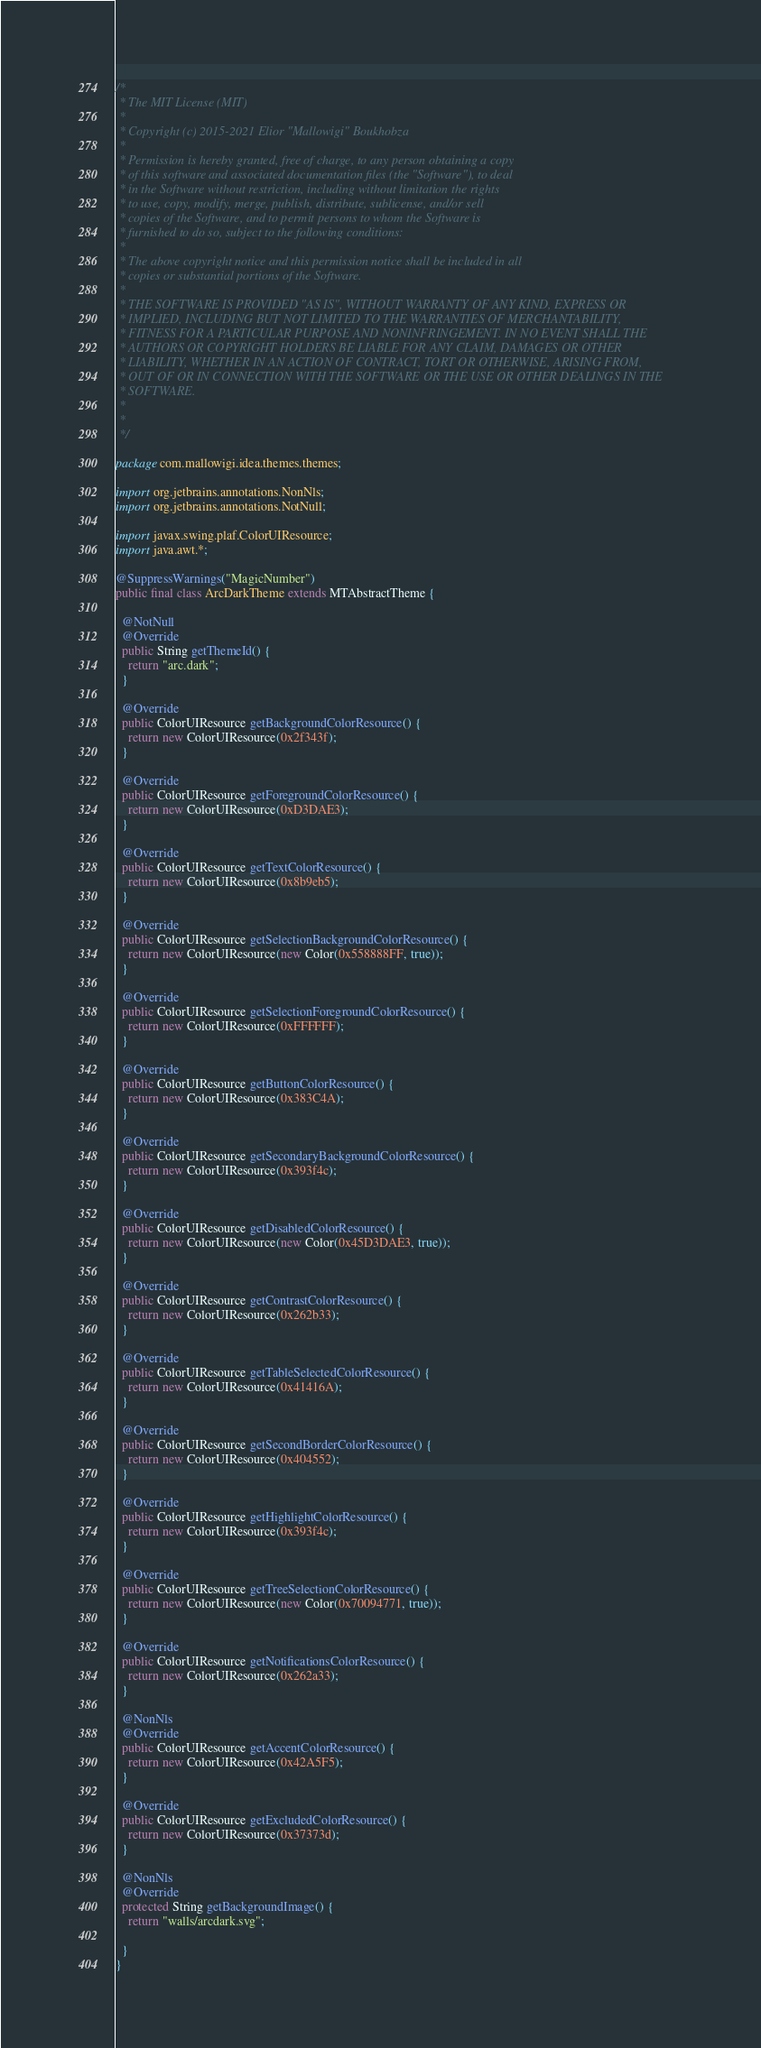Convert code to text. <code><loc_0><loc_0><loc_500><loc_500><_Java_>/*
 * The MIT License (MIT)
 *
 * Copyright (c) 2015-2021 Elior "Mallowigi" Boukhobza
 *
 * Permission is hereby granted, free of charge, to any person obtaining a copy
 * of this software and associated documentation files (the "Software"), to deal
 * in the Software without restriction, including without limitation the rights
 * to use, copy, modify, merge, publish, distribute, sublicense, and/or sell
 * copies of the Software, and to permit persons to whom the Software is
 * furnished to do so, subject to the following conditions:
 *
 * The above copyright notice and this permission notice shall be included in all
 * copies or substantial portions of the Software.
 *
 * THE SOFTWARE IS PROVIDED "AS IS", WITHOUT WARRANTY OF ANY KIND, EXPRESS OR
 * IMPLIED, INCLUDING BUT NOT LIMITED TO THE WARRANTIES OF MERCHANTABILITY,
 * FITNESS FOR A PARTICULAR PURPOSE AND NONINFRINGEMENT. IN NO EVENT SHALL THE
 * AUTHORS OR COPYRIGHT HOLDERS BE LIABLE FOR ANY CLAIM, DAMAGES OR OTHER
 * LIABILITY, WHETHER IN AN ACTION OF CONTRACT, TORT OR OTHERWISE, ARISING FROM,
 * OUT OF OR IN CONNECTION WITH THE SOFTWARE OR THE USE OR OTHER DEALINGS IN THE
 * SOFTWARE.
 *
 *
 */

package com.mallowigi.idea.themes.themes;

import org.jetbrains.annotations.NonNls;
import org.jetbrains.annotations.NotNull;

import javax.swing.plaf.ColorUIResource;
import java.awt.*;

@SuppressWarnings("MagicNumber")
public final class ArcDarkTheme extends MTAbstractTheme {

  @NotNull
  @Override
  public String getThemeId() {
    return "arc.dark";
  }

  @Override
  public ColorUIResource getBackgroundColorResource() {
    return new ColorUIResource(0x2f343f);
  }

  @Override
  public ColorUIResource getForegroundColorResource() {
    return new ColorUIResource(0xD3DAE3);
  }

  @Override
  public ColorUIResource getTextColorResource() {
    return new ColorUIResource(0x8b9eb5);
  }

  @Override
  public ColorUIResource getSelectionBackgroundColorResource() {
    return new ColorUIResource(new Color(0x558888FF, true));
  }

  @Override
  public ColorUIResource getSelectionForegroundColorResource() {
    return new ColorUIResource(0xFFFFFF);
  }

  @Override
  public ColorUIResource getButtonColorResource() {
    return new ColorUIResource(0x383C4A);
  }

  @Override
  public ColorUIResource getSecondaryBackgroundColorResource() {
    return new ColorUIResource(0x393f4c);
  }

  @Override
  public ColorUIResource getDisabledColorResource() {
    return new ColorUIResource(new Color(0x45D3DAE3, true));
  }

  @Override
  public ColorUIResource getContrastColorResource() {
    return new ColorUIResource(0x262b33);
  }

  @Override
  public ColorUIResource getTableSelectedColorResource() {
    return new ColorUIResource(0x41416A);
  }

  @Override
  public ColorUIResource getSecondBorderColorResource() {
    return new ColorUIResource(0x404552);
  }

  @Override
  public ColorUIResource getHighlightColorResource() {
    return new ColorUIResource(0x393f4c);
  }

  @Override
  public ColorUIResource getTreeSelectionColorResource() {
    return new ColorUIResource(new Color(0x70094771, true));
  }

  @Override
  public ColorUIResource getNotificationsColorResource() {
    return new ColorUIResource(0x262a33);
  }

  @NonNls
  @Override
  public ColorUIResource getAccentColorResource() {
    return new ColorUIResource(0x42A5F5);
  }

  @Override
  public ColorUIResource getExcludedColorResource() {
    return new ColorUIResource(0x37373d);
  }

  @NonNls
  @Override
  protected String getBackgroundImage() {
    return "walls/arcdark.svg";

  }
}
</code> 